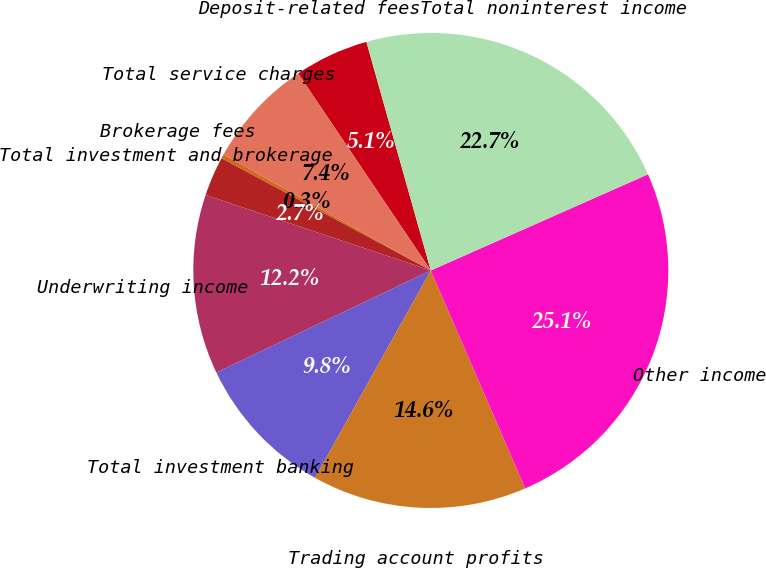Convert chart to OTSL. <chart><loc_0><loc_0><loc_500><loc_500><pie_chart><fcel>Deposit-related fees<fcel>Total service charges<fcel>Brokerage fees<fcel>Total investment and brokerage<fcel>Underwriting income<fcel>Total investment banking<fcel>Trading account profits<fcel>Other income<fcel>Total noninterest income<nl><fcel>5.06%<fcel>7.45%<fcel>0.29%<fcel>2.68%<fcel>12.22%<fcel>9.83%<fcel>14.61%<fcel>25.13%<fcel>22.74%<nl></chart> 